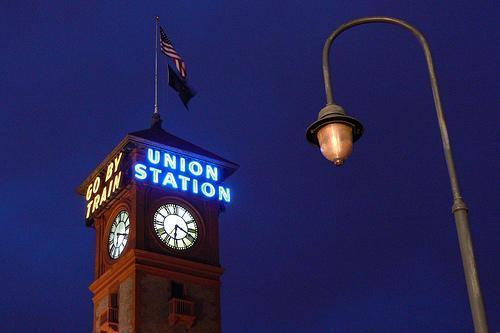How many clock faces are there?
Give a very brief answer. 2. 